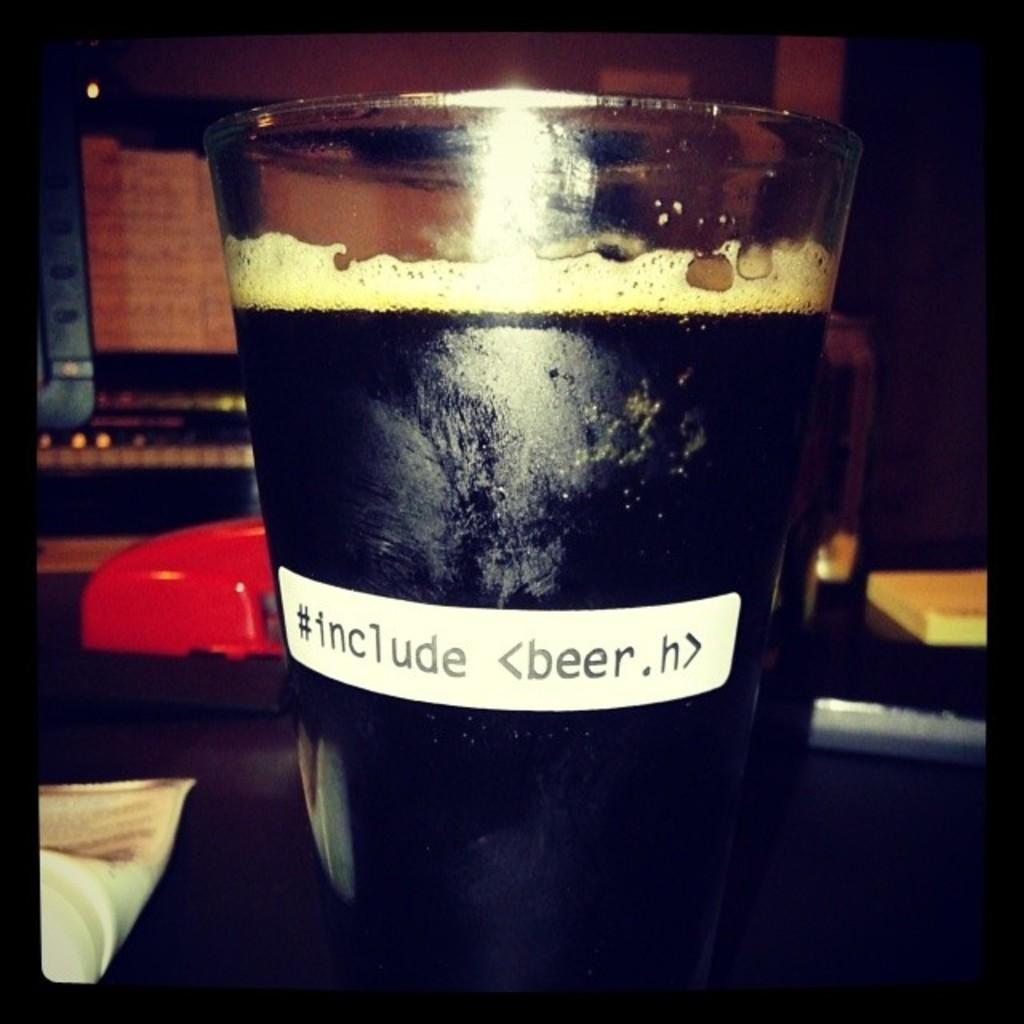Provide a one-sentence caption for the provided image. A glass of dark beer with writing of #include <beer.h>. 